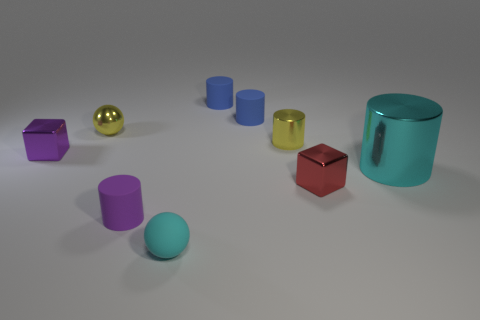Which objects are spherical? There is one spherical object in the image, and it's colored gold. 